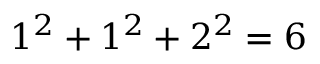<formula> <loc_0><loc_0><loc_500><loc_500>1 ^ { 2 } + 1 ^ { 2 } + 2 ^ { 2 } = 6</formula> 